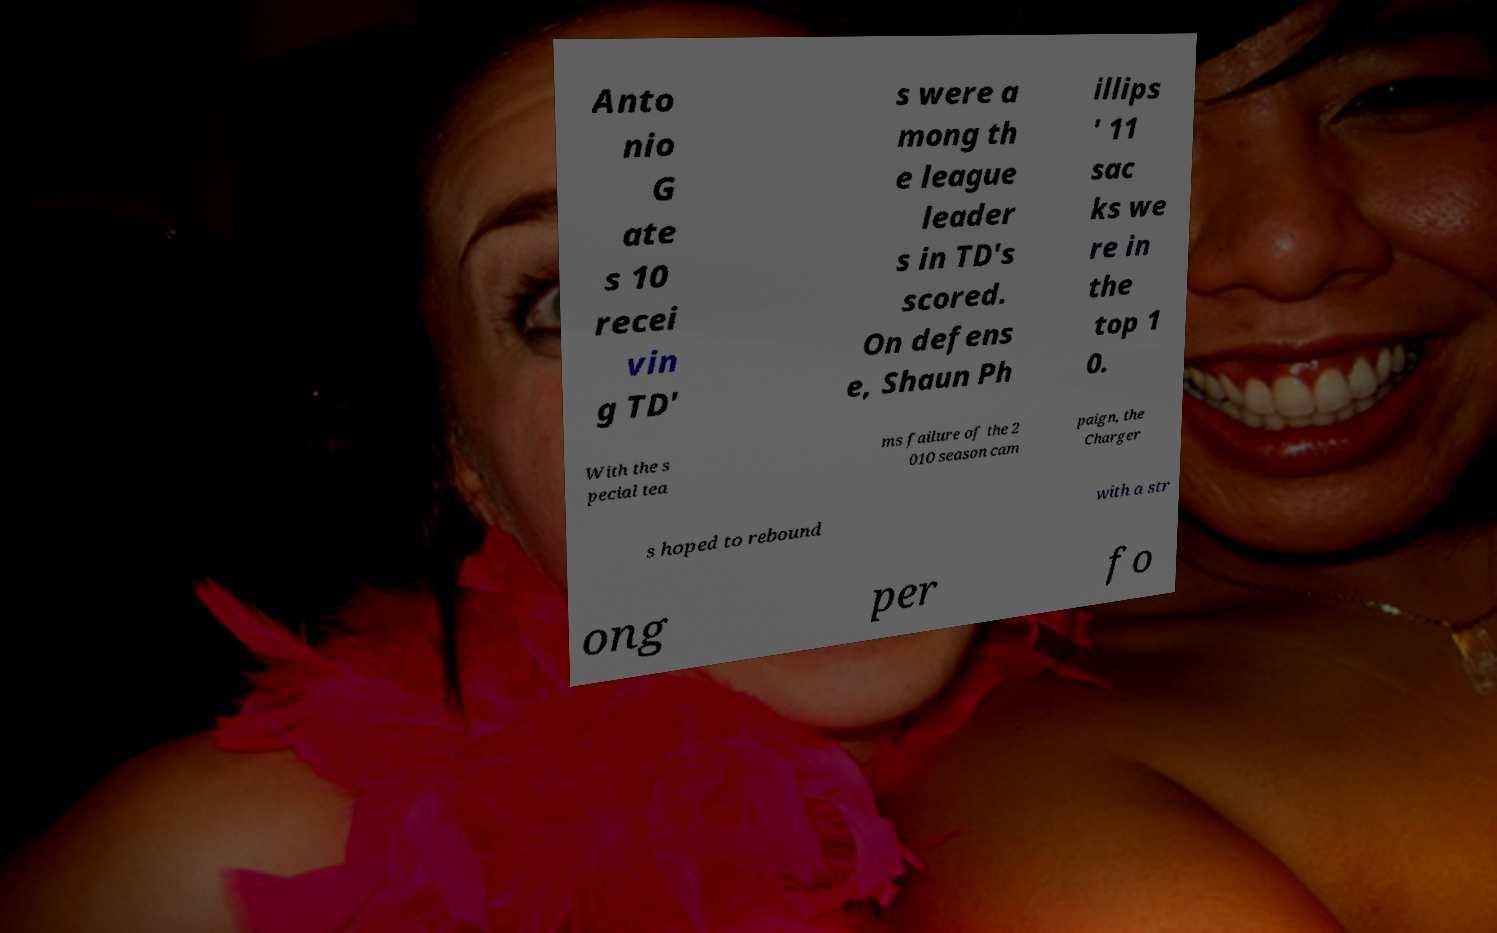Can you accurately transcribe the text from the provided image for me? Anto nio G ate s 10 recei vin g TD' s were a mong th e league leader s in TD's scored. On defens e, Shaun Ph illips ' 11 sac ks we re in the top 1 0. With the s pecial tea ms failure of the 2 010 season cam paign, the Charger s hoped to rebound with a str ong per fo 